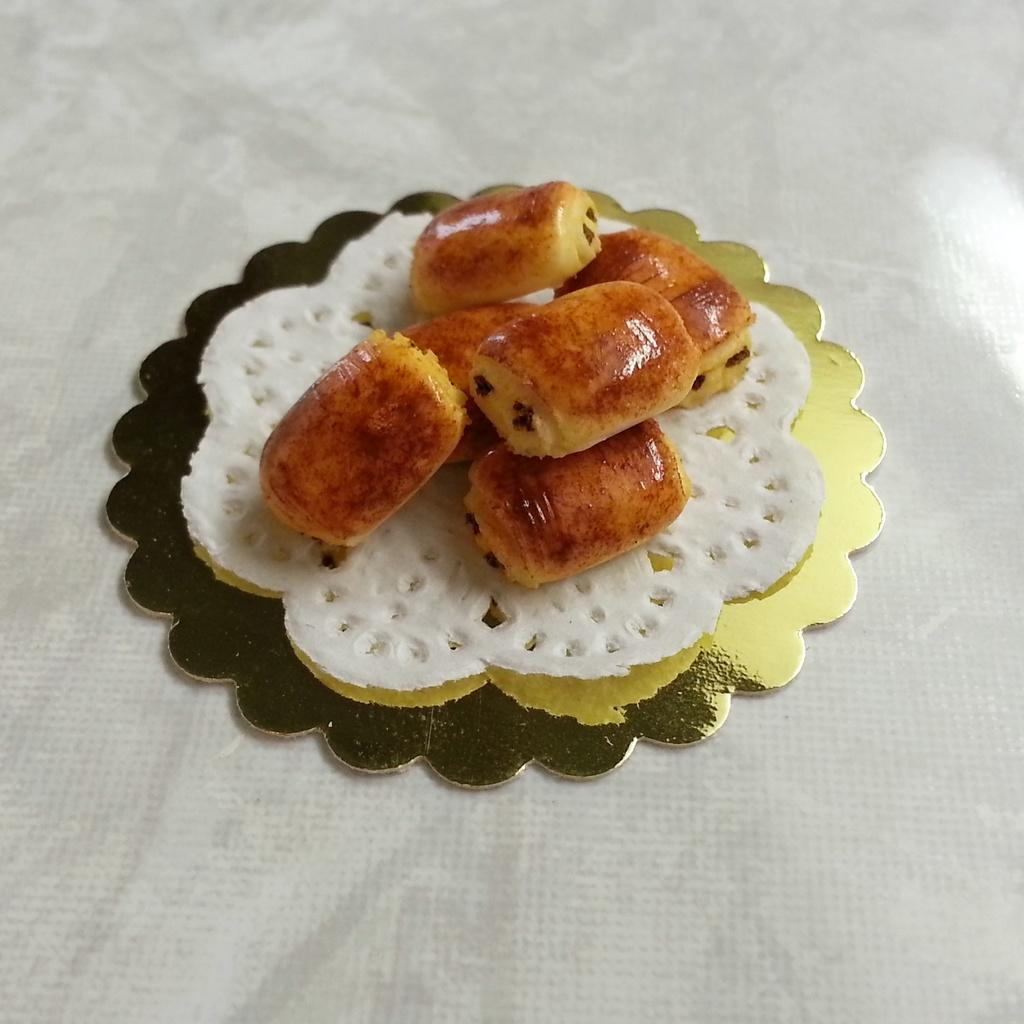What type of items can be seen in the image? There are food items in the image. Where are the food items placed? The food items are placed on a white object. What is the white object made of? The white object appears to be tissue paper. How many chairs can be seen in the image? There are no chairs present in the image. What type of cakes are being served in the image? There is no mention of cakes in the provided facts, and therefore we cannot determine if any cakes are present in the image. 